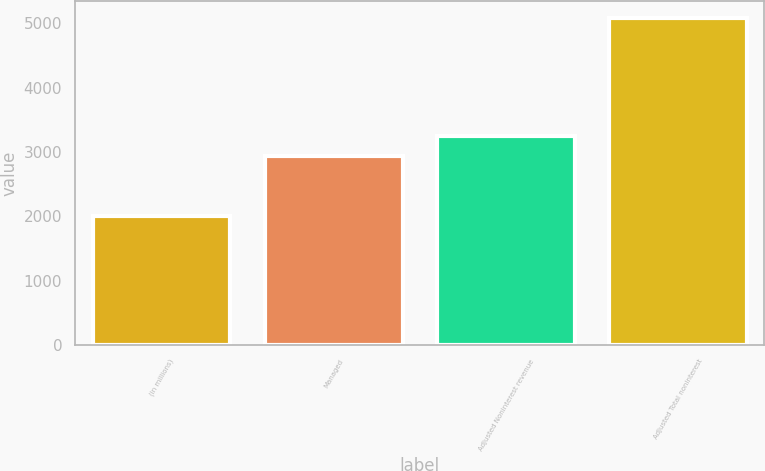Convert chart. <chart><loc_0><loc_0><loc_500><loc_500><bar_chart><fcel>(in millions)<fcel>Managed<fcel>Adjusted Noninterest revenue<fcel>Adjusted Total noninterest<nl><fcel>2006<fcel>2944<fcel>3252<fcel>5086<nl></chart> 